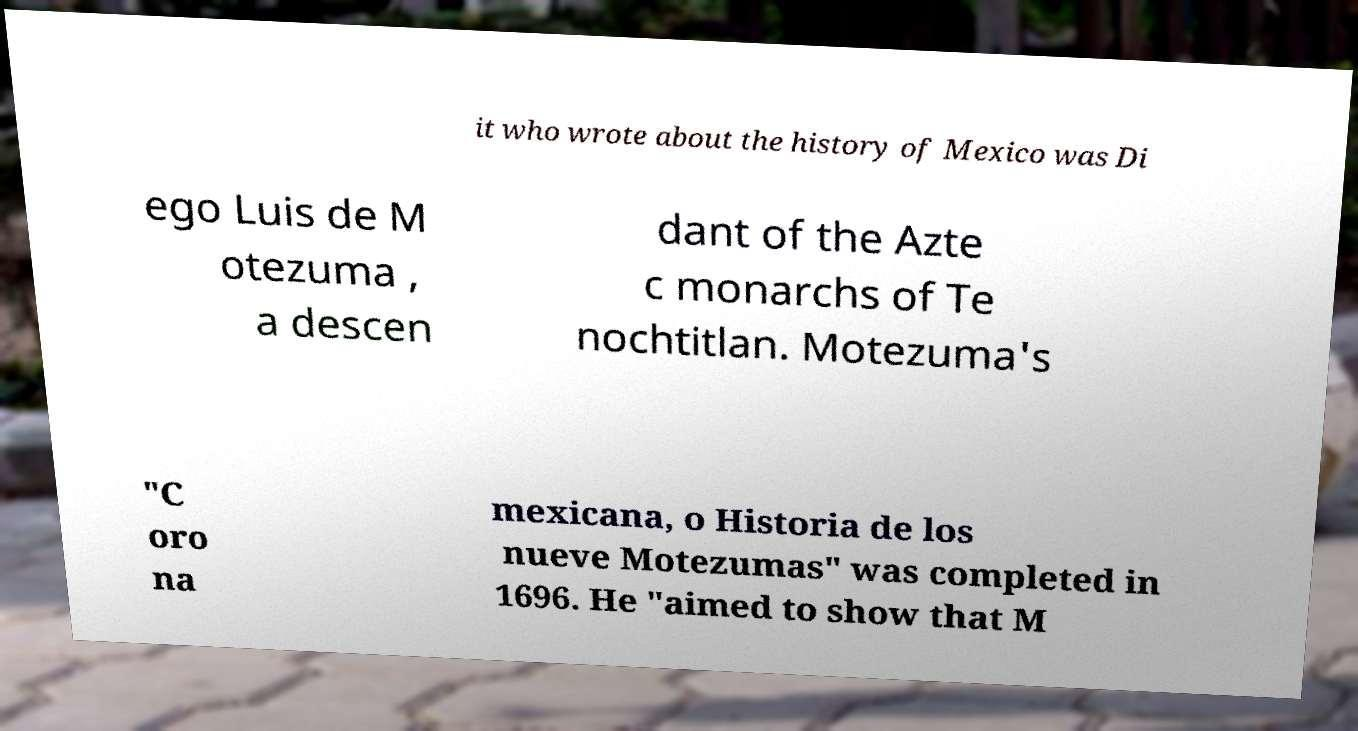Could you assist in decoding the text presented in this image and type it out clearly? it who wrote about the history of Mexico was Di ego Luis de M otezuma , a descen dant of the Azte c monarchs of Te nochtitlan. Motezuma's "C oro na mexicana, o Historia de los nueve Motezumas" was completed in 1696. He "aimed to show that M 